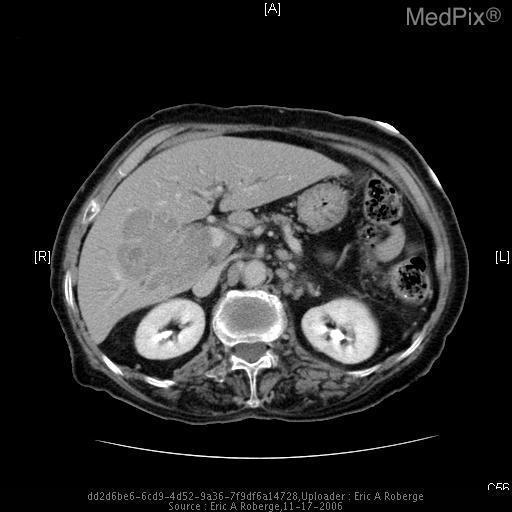Is there intrahepatic ductal dilatation?
Write a very short answer. Yes. Is intrahepatic ductal dilatation present?
Concise answer only. Yes. Is there evidence of mesenteric lymphadenopathy?
Short answer required. Yes. Is mesenteric lymphadenopathy present?
Be succinct. Yes. What imaging modality was used?
Concise answer only. Ct. Is the mass in the liver regular or irregular in contour?
Keep it brief. Irregular. What is the shape of the liver mass?
Short answer required. Infiltrative. 